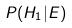<formula> <loc_0><loc_0><loc_500><loc_500>P ( H _ { 1 } | E )</formula> 